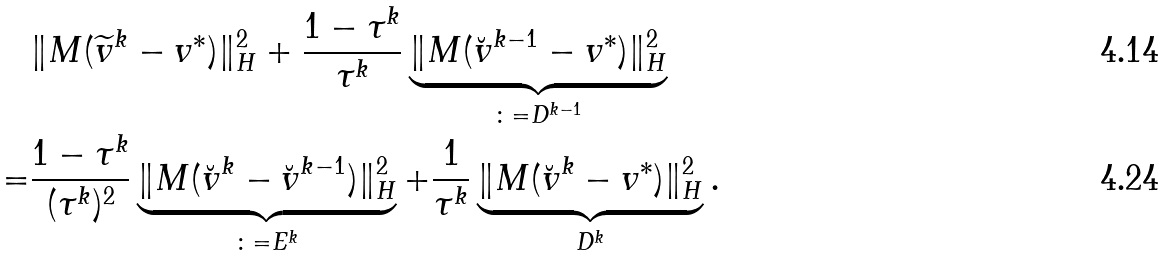Convert formula to latex. <formula><loc_0><loc_0><loc_500><loc_500>& \| M ( \widetilde { v } ^ { k } - v ^ { * } ) \| ^ { 2 } _ { H } + \frac { 1 - \tau ^ { k } } { \tau ^ { k } } \underbrace { \| M ( \breve { v } ^ { k - 1 } - v ^ { * } ) \| ^ { 2 } _ { H } } _ { \colon = D ^ { k - 1 } } \\ = & \frac { 1 - \tau ^ { k } } { ( \tau ^ { k } ) ^ { 2 } } \underbrace { \| M ( \breve { v } ^ { k } - \breve { v } ^ { k - 1 } ) \| ^ { 2 } _ { H } } _ { \colon = E ^ { k } } + \frac { 1 } { \tau ^ { k } } \underbrace { \| M ( \breve { v } ^ { k } - v ^ { * } ) \| ^ { 2 } _ { H } } _ { D ^ { k } } .</formula> 